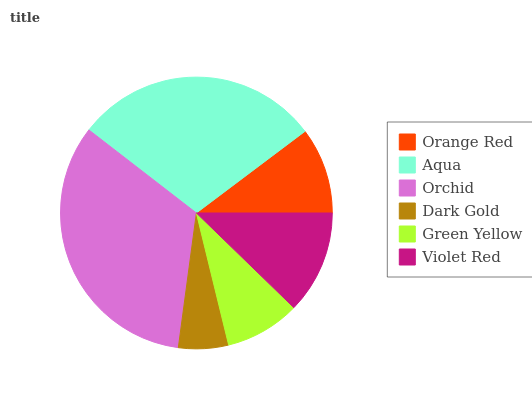Is Dark Gold the minimum?
Answer yes or no. Yes. Is Orchid the maximum?
Answer yes or no. Yes. Is Aqua the minimum?
Answer yes or no. No. Is Aqua the maximum?
Answer yes or no. No. Is Aqua greater than Orange Red?
Answer yes or no. Yes. Is Orange Red less than Aqua?
Answer yes or no. Yes. Is Orange Red greater than Aqua?
Answer yes or no. No. Is Aqua less than Orange Red?
Answer yes or no. No. Is Violet Red the high median?
Answer yes or no. Yes. Is Orange Red the low median?
Answer yes or no. Yes. Is Orchid the high median?
Answer yes or no. No. Is Violet Red the low median?
Answer yes or no. No. 